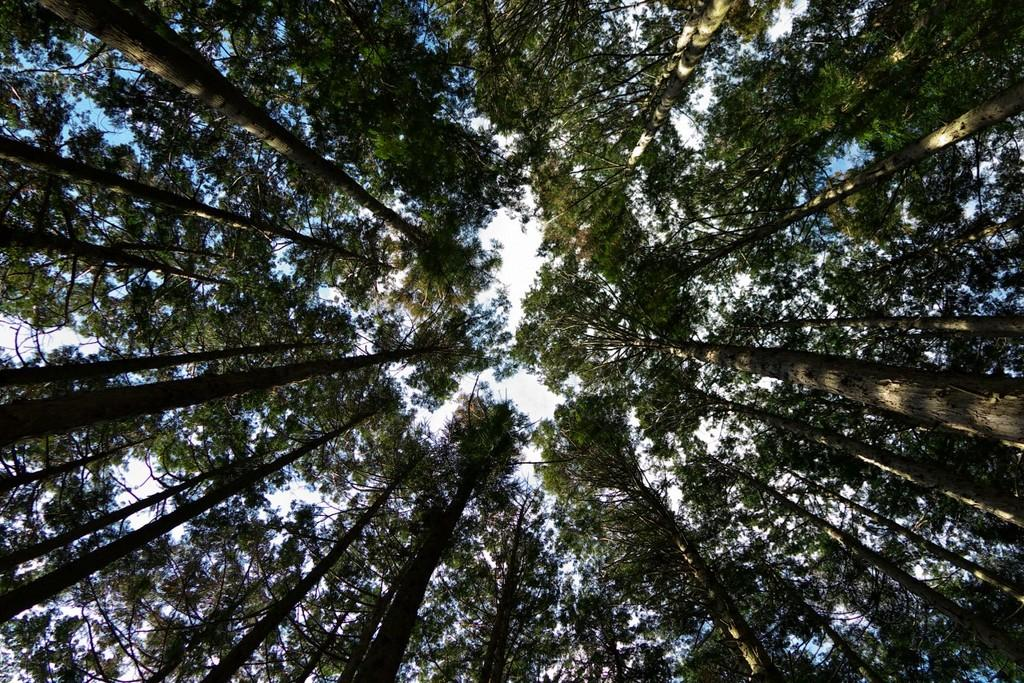What type of vegetation can be seen in the image? There are trees in the image. What is the color of the trees? The trees are green in color. What else can be seen in the background of the image? The sky is visible in the background of the image. What type of cheese is hanging from the branches of the trees in the image? There is no cheese present in the image; it features trees with green leaves. Are there any jeans visible on the trees in the image? There are no jeans present in the image; it features trees with green leaves. 